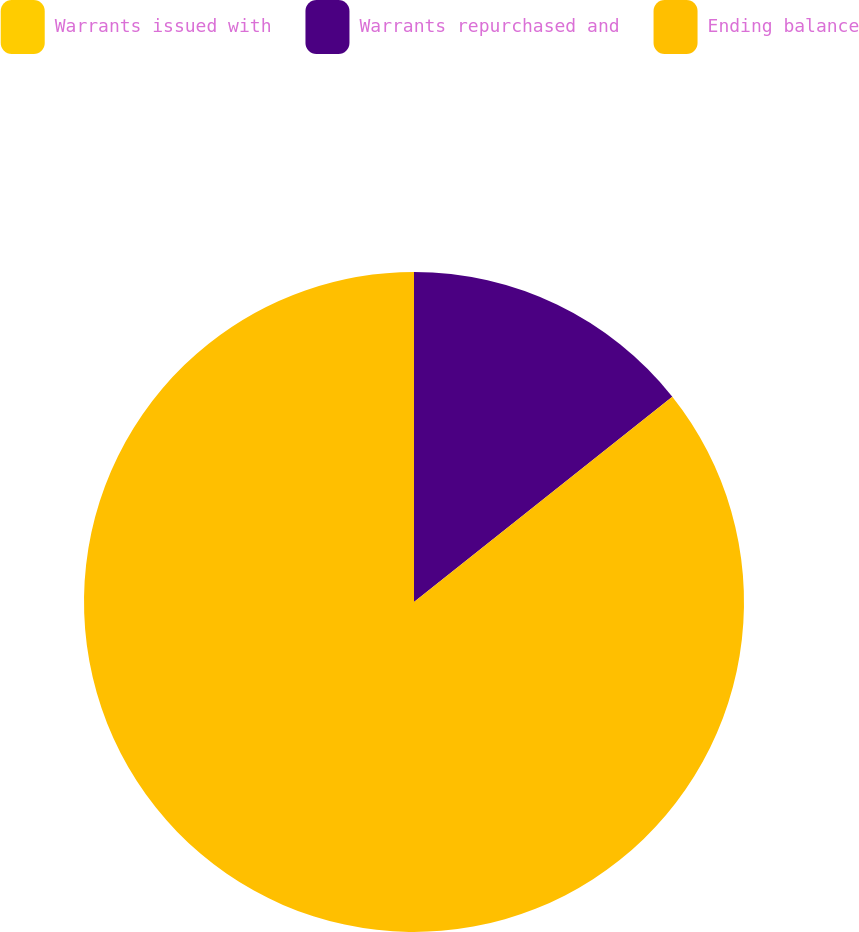<chart> <loc_0><loc_0><loc_500><loc_500><pie_chart><fcel>Warrants issued with<fcel>Warrants repurchased and<fcel>Ending balance<nl><fcel>0.0%<fcel>14.31%<fcel>85.69%<nl></chart> 